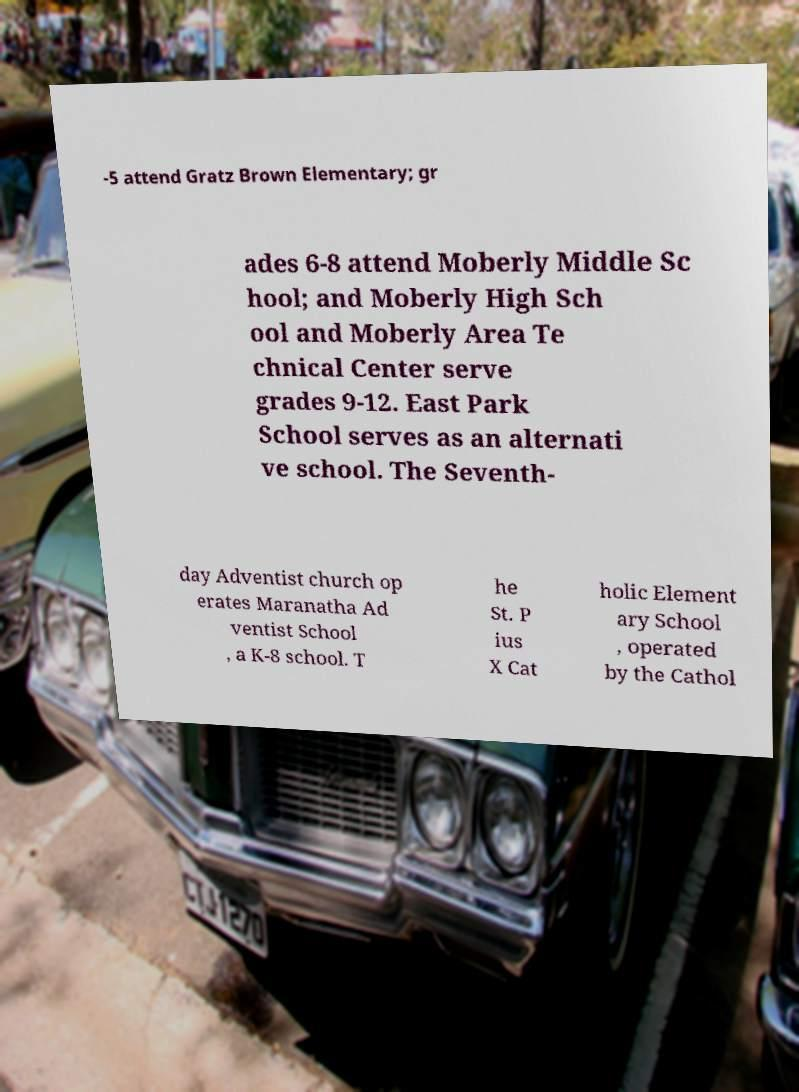There's text embedded in this image that I need extracted. Can you transcribe it verbatim? -5 attend Gratz Brown Elementary; gr ades 6-8 attend Moberly Middle Sc hool; and Moberly High Sch ool and Moberly Area Te chnical Center serve grades 9-12. East Park School serves as an alternati ve school. The Seventh- day Adventist church op erates Maranatha Ad ventist School , a K-8 school. T he St. P ius X Cat holic Element ary School , operated by the Cathol 